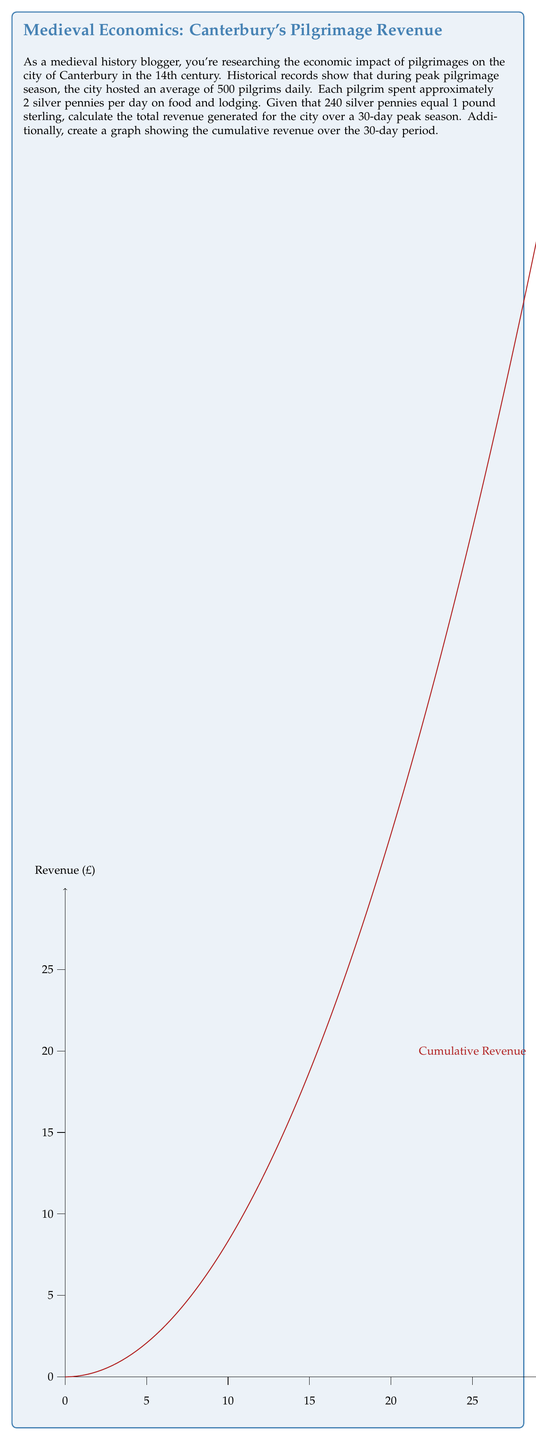What is the answer to this math problem? Let's break this problem down step-by-step:

1) First, let's calculate the daily revenue:
   - 500 pilgrims per day
   - Each pilgrim spends 2 silver pennies
   - Daily revenue in pennies: $500 \times 2 = 1000$ pennies

2) Convert daily revenue to pounds sterling:
   - 240 pennies = 1 pound sterling
   - Daily revenue in pounds: $\frac{1000}{240} = \frac{25}{6} \approx 4.17$ pounds

3) Calculate total revenue over 30 days:
   - $\frac{25}{6} \times 30 = 125$ pounds sterling

4) For the graph, we need to calculate cumulative revenue each day:
   - Day 1: $\frac{25}{6}$ pounds
   - Day 2: $2 \times \frac{25}{6}$ pounds
   - ...
   - Day 30: $30 \times \frac{25}{6} = 125$ pounds

The equation for cumulative revenue on day $n$ is:

$$ R(n) = n \times \frac{25}{6} = \frac{25n}{6} $$

This forms a linear equation, which explains the straight line in the graph.

The graph shows the cumulative revenue increasing linearly over the 30-day period, starting from 0 and reaching 125 pounds on day 30.
Answer: 125 pounds sterling 